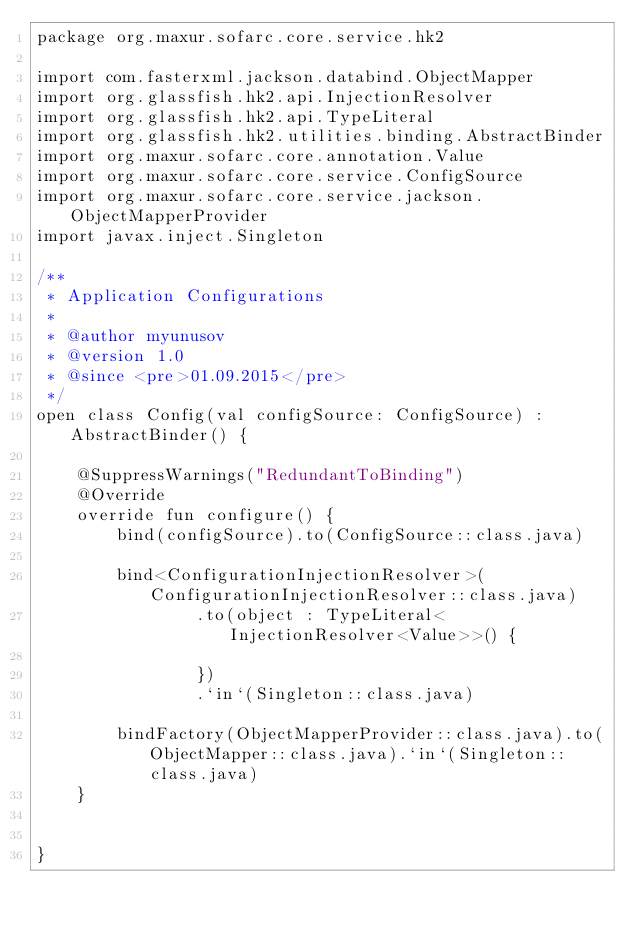Convert code to text. <code><loc_0><loc_0><loc_500><loc_500><_Kotlin_>package org.maxur.sofarc.core.service.hk2

import com.fasterxml.jackson.databind.ObjectMapper
import org.glassfish.hk2.api.InjectionResolver
import org.glassfish.hk2.api.TypeLiteral
import org.glassfish.hk2.utilities.binding.AbstractBinder
import org.maxur.sofarc.core.annotation.Value
import org.maxur.sofarc.core.service.ConfigSource
import org.maxur.sofarc.core.service.jackson.ObjectMapperProvider
import javax.inject.Singleton

/**
 * Application Configurations
 *
 * @author myunusov
 * @version 1.0
 * @since <pre>01.09.2015</pre>
 */
open class Config(val configSource: ConfigSource) : AbstractBinder() {

    @SuppressWarnings("RedundantToBinding")
    @Override
    override fun configure() {
        bind(configSource).to(ConfigSource::class.java)

        bind<ConfigurationInjectionResolver>(ConfigurationInjectionResolver::class.java)
                .to(object : TypeLiteral<InjectionResolver<Value>>() {

                })
                .`in`(Singleton::class.java)

        bindFactory(ObjectMapperProvider::class.java).to(ObjectMapper::class.java).`in`(Singleton::class.java)
    }


}
</code> 